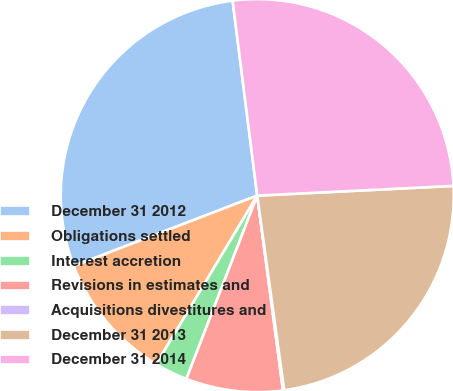Convert chart. <chart><loc_0><loc_0><loc_500><loc_500><pie_chart><fcel>December 31 2012<fcel>Obligations settled<fcel>Interest accretion<fcel>Revisions in estimates and<fcel>Acquisitions divestitures and<fcel>December 31 2013<fcel>December 31 2014<nl><fcel>28.83%<fcel>10.58%<fcel>2.72%<fcel>7.96%<fcel>0.1%<fcel>23.59%<fcel>26.21%<nl></chart> 